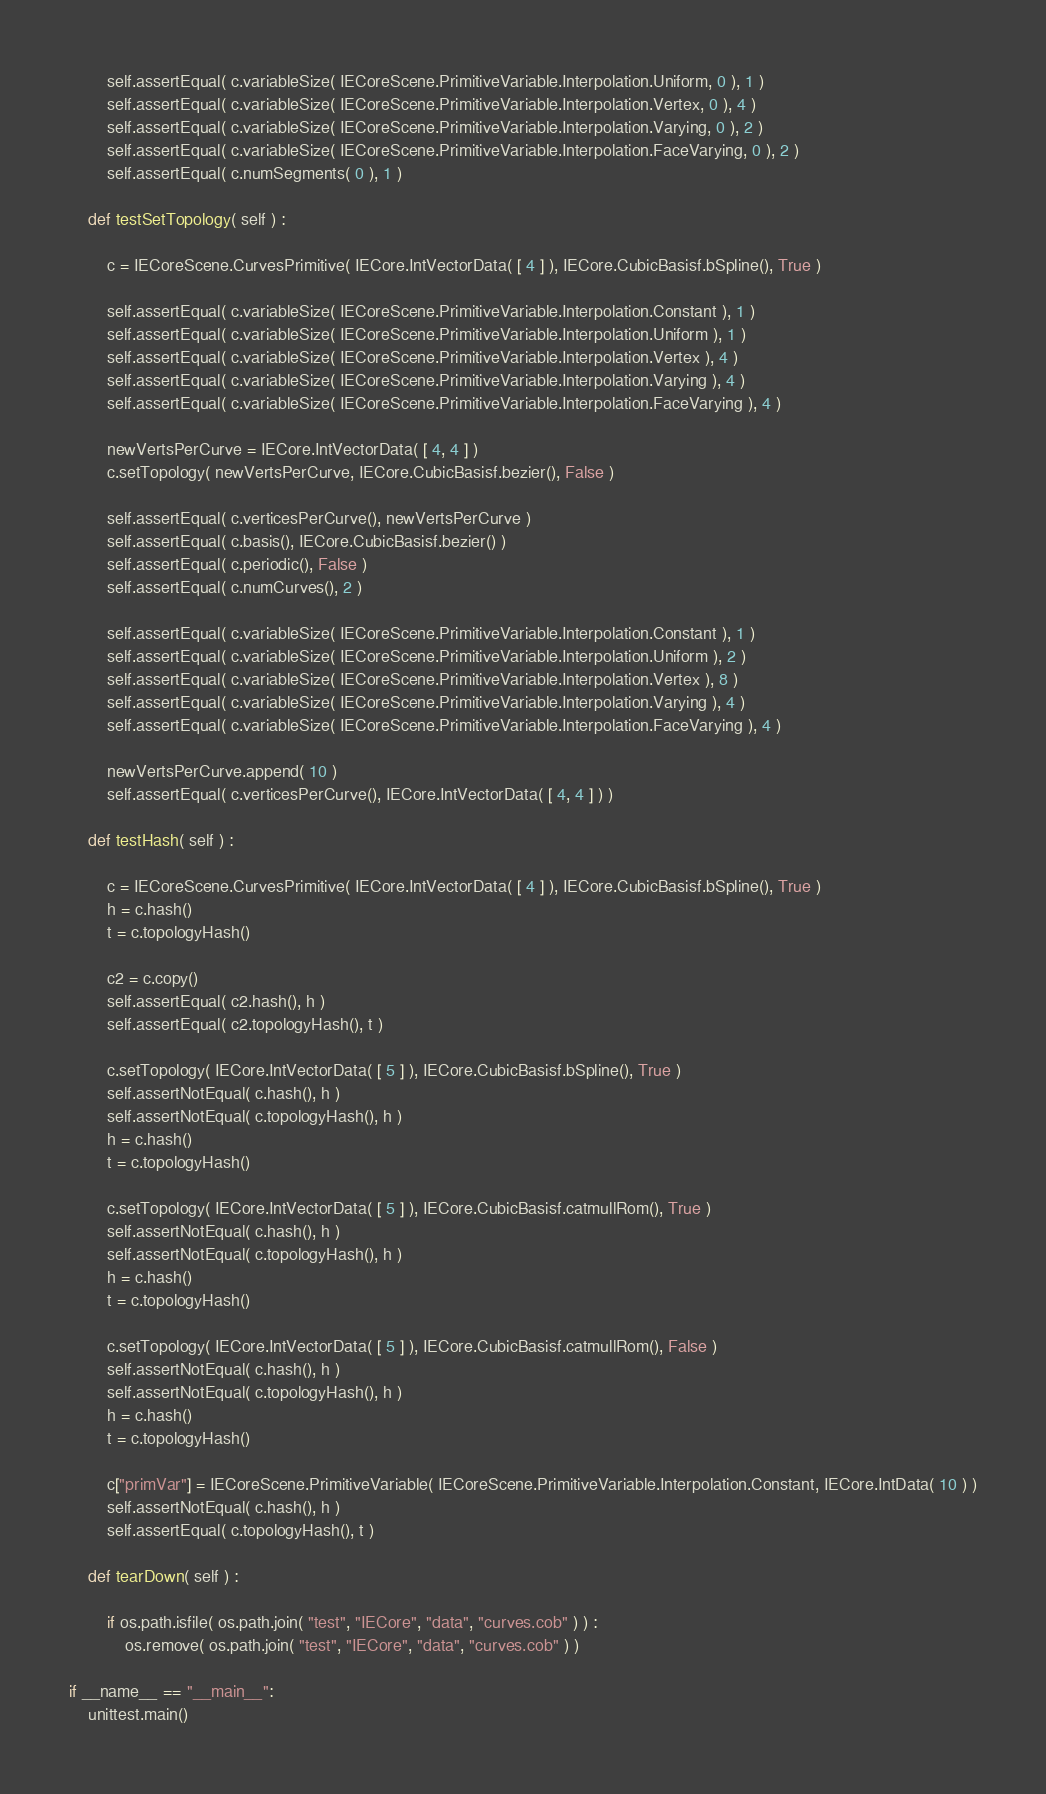Convert code to text. <code><loc_0><loc_0><loc_500><loc_500><_Python_>		self.assertEqual( c.variableSize( IECoreScene.PrimitiveVariable.Interpolation.Uniform, 0 ), 1 )
		self.assertEqual( c.variableSize( IECoreScene.PrimitiveVariable.Interpolation.Vertex, 0 ), 4 )
		self.assertEqual( c.variableSize( IECoreScene.PrimitiveVariable.Interpolation.Varying, 0 ), 2 )
		self.assertEqual( c.variableSize( IECoreScene.PrimitiveVariable.Interpolation.FaceVarying, 0 ), 2 )
		self.assertEqual( c.numSegments( 0 ), 1 )

	def testSetTopology( self ) :

		c = IECoreScene.CurvesPrimitive( IECore.IntVectorData( [ 4 ] ), IECore.CubicBasisf.bSpline(), True )

		self.assertEqual( c.variableSize( IECoreScene.PrimitiveVariable.Interpolation.Constant ), 1 )
		self.assertEqual( c.variableSize( IECoreScene.PrimitiveVariable.Interpolation.Uniform ), 1 )
		self.assertEqual( c.variableSize( IECoreScene.PrimitiveVariable.Interpolation.Vertex ), 4 )
		self.assertEqual( c.variableSize( IECoreScene.PrimitiveVariable.Interpolation.Varying ), 4 )
		self.assertEqual( c.variableSize( IECoreScene.PrimitiveVariable.Interpolation.FaceVarying ), 4 )

		newVertsPerCurve = IECore.IntVectorData( [ 4, 4 ] )
		c.setTopology( newVertsPerCurve, IECore.CubicBasisf.bezier(), False )

		self.assertEqual( c.verticesPerCurve(), newVertsPerCurve )
		self.assertEqual( c.basis(), IECore.CubicBasisf.bezier() )
		self.assertEqual( c.periodic(), False )
		self.assertEqual( c.numCurves(), 2 )

		self.assertEqual( c.variableSize( IECoreScene.PrimitiveVariable.Interpolation.Constant ), 1 )
		self.assertEqual( c.variableSize( IECoreScene.PrimitiveVariable.Interpolation.Uniform ), 2 )
		self.assertEqual( c.variableSize( IECoreScene.PrimitiveVariable.Interpolation.Vertex ), 8 )
		self.assertEqual( c.variableSize( IECoreScene.PrimitiveVariable.Interpolation.Varying ), 4 )
		self.assertEqual( c.variableSize( IECoreScene.PrimitiveVariable.Interpolation.FaceVarying ), 4 )

		newVertsPerCurve.append( 10 )
		self.assertEqual( c.verticesPerCurve(), IECore.IntVectorData( [ 4, 4 ] ) )

	def testHash( self ) :

		c = IECoreScene.CurvesPrimitive( IECore.IntVectorData( [ 4 ] ), IECore.CubicBasisf.bSpline(), True )
		h = c.hash()
		t = c.topologyHash()

		c2 = c.copy()
		self.assertEqual( c2.hash(), h )
		self.assertEqual( c2.topologyHash(), t )

		c.setTopology( IECore.IntVectorData( [ 5 ] ), IECore.CubicBasisf.bSpline(), True )
		self.assertNotEqual( c.hash(), h )
		self.assertNotEqual( c.topologyHash(), h )
		h = c.hash()
		t = c.topologyHash()

		c.setTopology( IECore.IntVectorData( [ 5 ] ), IECore.CubicBasisf.catmullRom(), True )
		self.assertNotEqual( c.hash(), h )
		self.assertNotEqual( c.topologyHash(), h )
		h = c.hash()
		t = c.topologyHash()

		c.setTopology( IECore.IntVectorData( [ 5 ] ), IECore.CubicBasisf.catmullRom(), False )
		self.assertNotEqual( c.hash(), h )
		self.assertNotEqual( c.topologyHash(), h )
		h = c.hash()
		t = c.topologyHash()

		c["primVar"] = IECoreScene.PrimitiveVariable( IECoreScene.PrimitiveVariable.Interpolation.Constant, IECore.IntData( 10 ) )
		self.assertNotEqual( c.hash(), h )
		self.assertEqual( c.topologyHash(), t )

	def tearDown( self ) :

		if os.path.isfile( os.path.join( "test", "IECore", "data", "curves.cob" ) ) :
			os.remove( os.path.join( "test", "IECore", "data", "curves.cob" ) )

if __name__ == "__main__":
    unittest.main()

</code> 